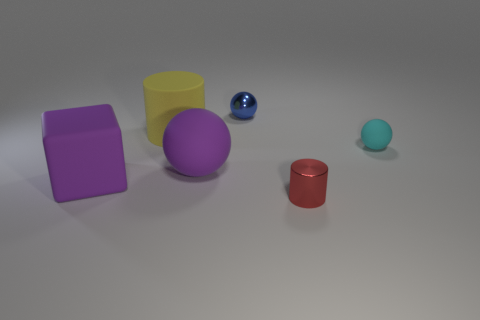There is a object that is the same color as the big matte block; what is it made of?
Offer a very short reply. Rubber. What number of objects are objects that are on the left side of the large yellow cylinder or purple matte things?
Provide a succinct answer. 2. There is a metal object in front of the small cyan ball; what is its shape?
Provide a succinct answer. Cylinder. Is the number of tiny red shiny objects that are behind the purple rubber ball the same as the number of cyan matte objects in front of the purple matte cube?
Your answer should be very brief. Yes. What is the color of the large object that is both right of the block and in front of the large cylinder?
Give a very brief answer. Purple. The cylinder that is behind the small ball in front of the blue ball is made of what material?
Give a very brief answer. Rubber. Do the yellow object and the metallic sphere have the same size?
Make the answer very short. No. How many big objects are cyan shiny spheres or blue balls?
Provide a short and direct response. 0. How many purple blocks are behind the red shiny object?
Keep it short and to the point. 1. Are there more small metal cylinders that are behind the tiny red metal object than small things?
Your answer should be very brief. No. 